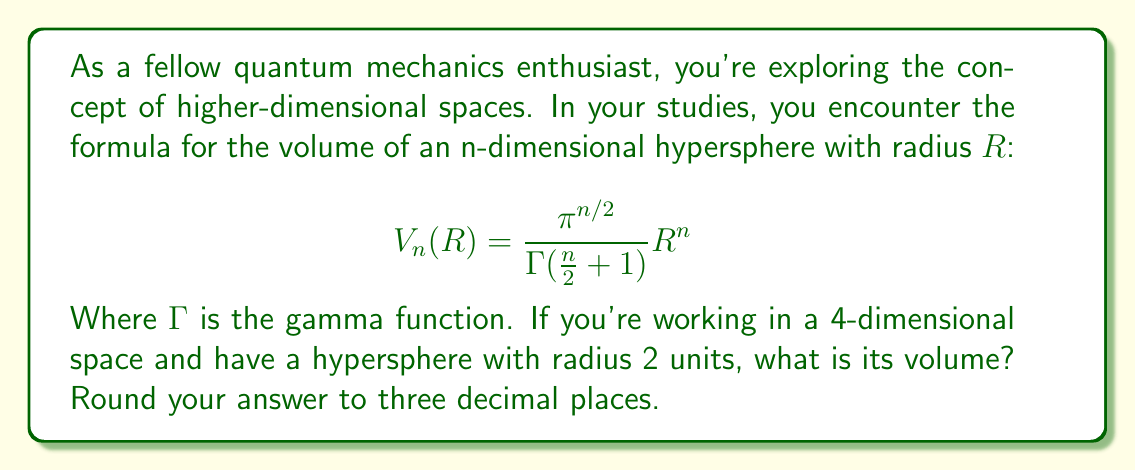Help me with this question. Let's approach this step-by-step:

1) We're given the formula for the volume of an n-dimensional hypersphere:
   $$ V_n(R) = \frac{\pi^{n/2}}{\Gamma(\frac{n}{2} + 1)} R^n $$

2) We're working in 4-dimensional space, so $n = 4$, and the radius $R = 2$.

3) Let's substitute these values into our formula:
   $$ V_4(2) = \frac{\pi^{4/2}}{\Gamma(\frac{4}{2} + 1)} 2^4 $$

4) Simplify:
   $$ V_4(2) = \frac{\pi^2}{\Gamma(3)} 16 $$

5) We know that $\Gamma(3) = 2! = 2$, so:
   $$ V_4(2) = \frac{\pi^2}{2} 16 = 8\pi^2 $$

6) Now, let's calculate this value:
   $$ 8\pi^2 \approx 8 * 9.8696 \approx 78.9568 $$

7) Rounding to three decimal places:
   $$ V_4(2) \approx 78.957 $$
Answer: $78.957$ 